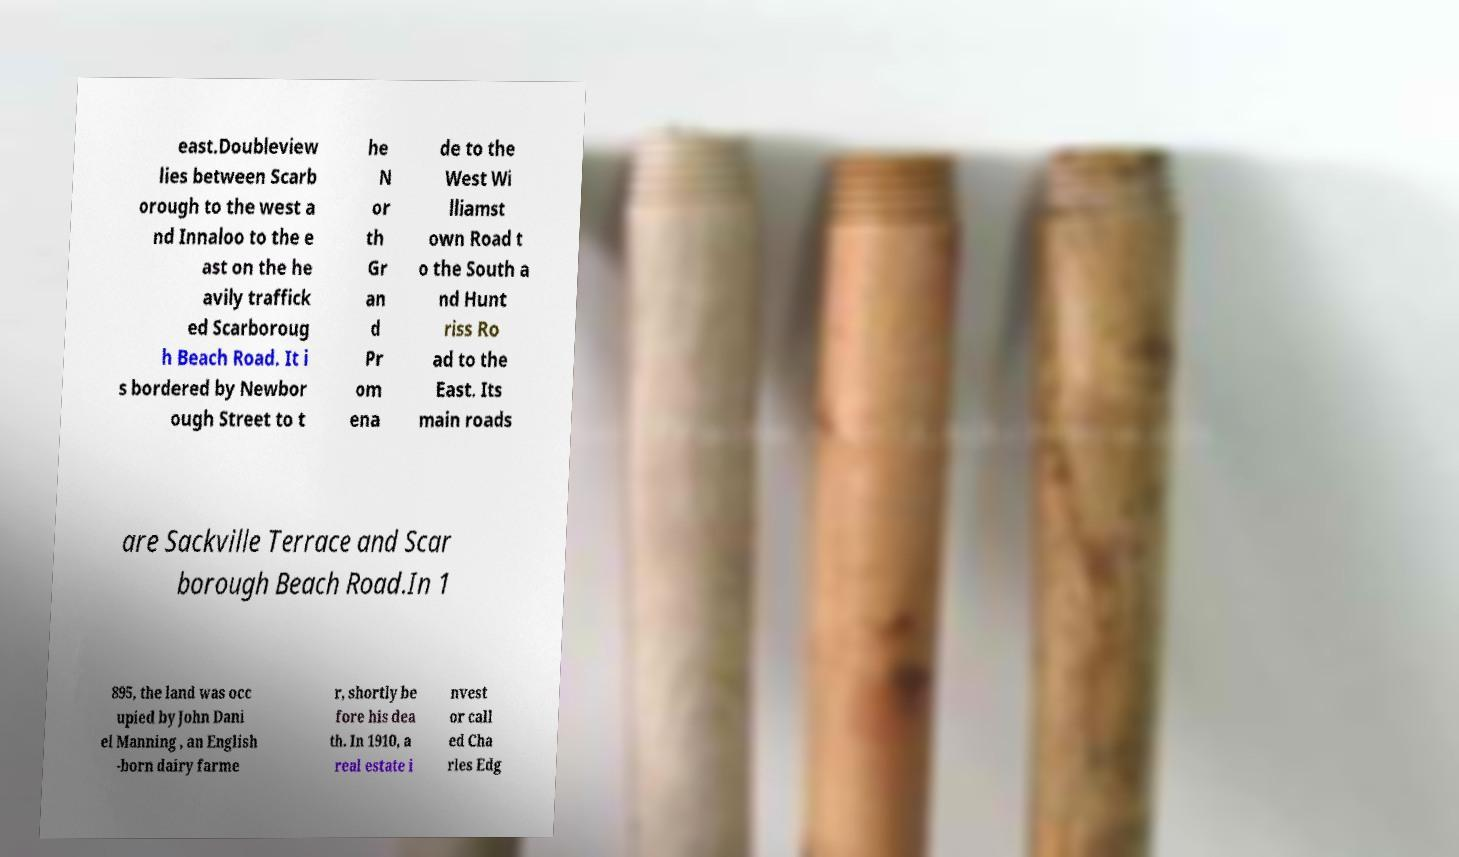Please read and relay the text visible in this image. What does it say? east.Doubleview lies between Scarb orough to the west a nd Innaloo to the e ast on the he avily traffick ed Scarboroug h Beach Road. It i s bordered by Newbor ough Street to t he N or th Gr an d Pr om ena de to the West Wi lliamst own Road t o the South a nd Hunt riss Ro ad to the East. Its main roads are Sackville Terrace and Scar borough Beach Road.In 1 895, the land was occ upied by John Dani el Manning , an English -born dairy farme r, shortly be fore his dea th. In 1910, a real estate i nvest or call ed Cha rles Edg 